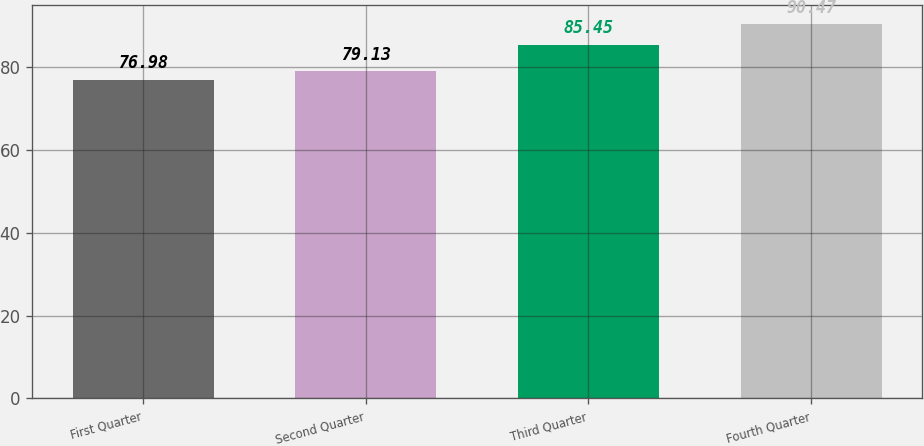Convert chart to OTSL. <chart><loc_0><loc_0><loc_500><loc_500><bar_chart><fcel>First Quarter<fcel>Second Quarter<fcel>Third Quarter<fcel>Fourth Quarter<nl><fcel>76.98<fcel>79.13<fcel>85.45<fcel>90.47<nl></chart> 